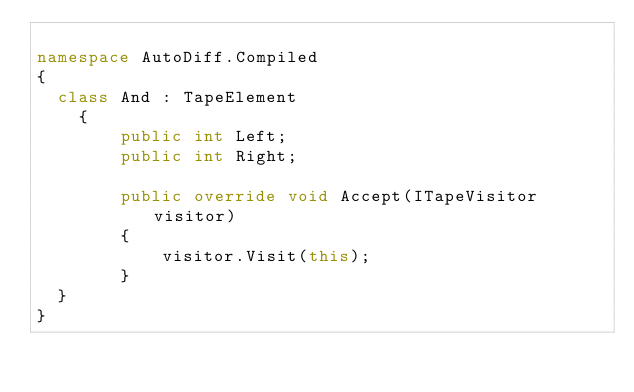<code> <loc_0><loc_0><loc_500><loc_500><_C#_>
namespace AutoDiff.Compiled
{
	class And : TapeElement
    {
        public int Left;
        public int Right;

        public override void Accept(ITapeVisitor visitor)
        {
            visitor.Visit(this);
        }
	}
}
</code> 